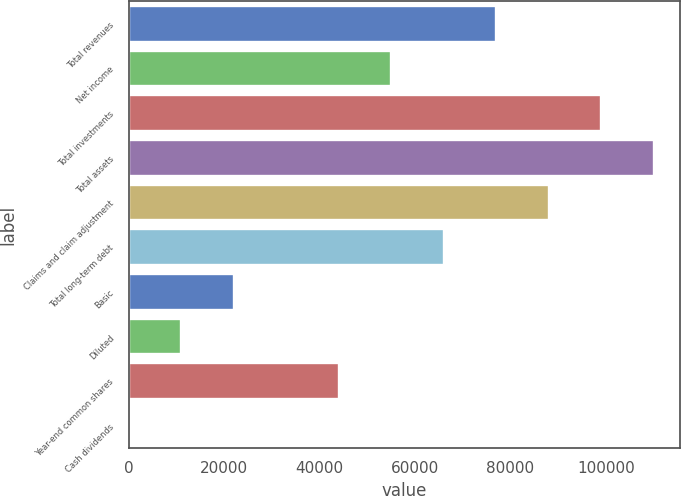Convert chart to OTSL. <chart><loc_0><loc_0><loc_500><loc_500><bar_chart><fcel>Total revenues<fcel>Net income<fcel>Total investments<fcel>Total assets<fcel>Claims and claim adjustment<fcel>Total long-term debt<fcel>Basic<fcel>Diluted<fcel>Year-end common shares<fcel>Cash dividends<nl><fcel>77009.5<fcel>55007.1<fcel>99011.9<fcel>110013<fcel>88010.7<fcel>66008.3<fcel>22003.6<fcel>11002.4<fcel>44005.9<fcel>1.23<nl></chart> 